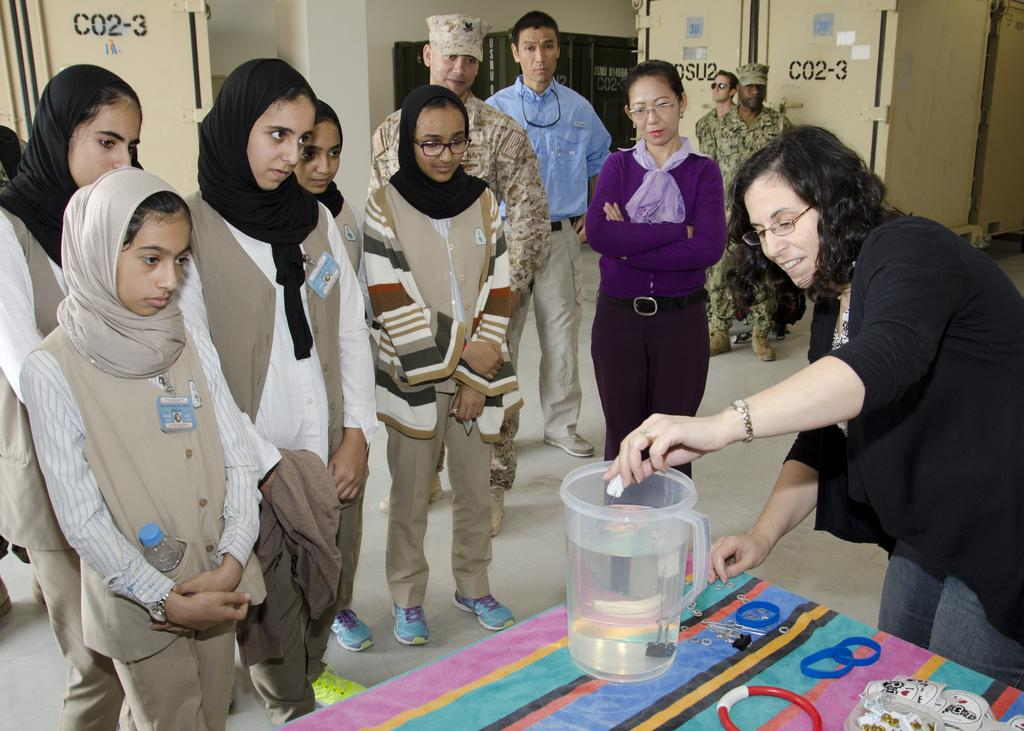<image>
Relay a brief, clear account of the picture shown. Several people stand in a room with lockers that read CO2-3 